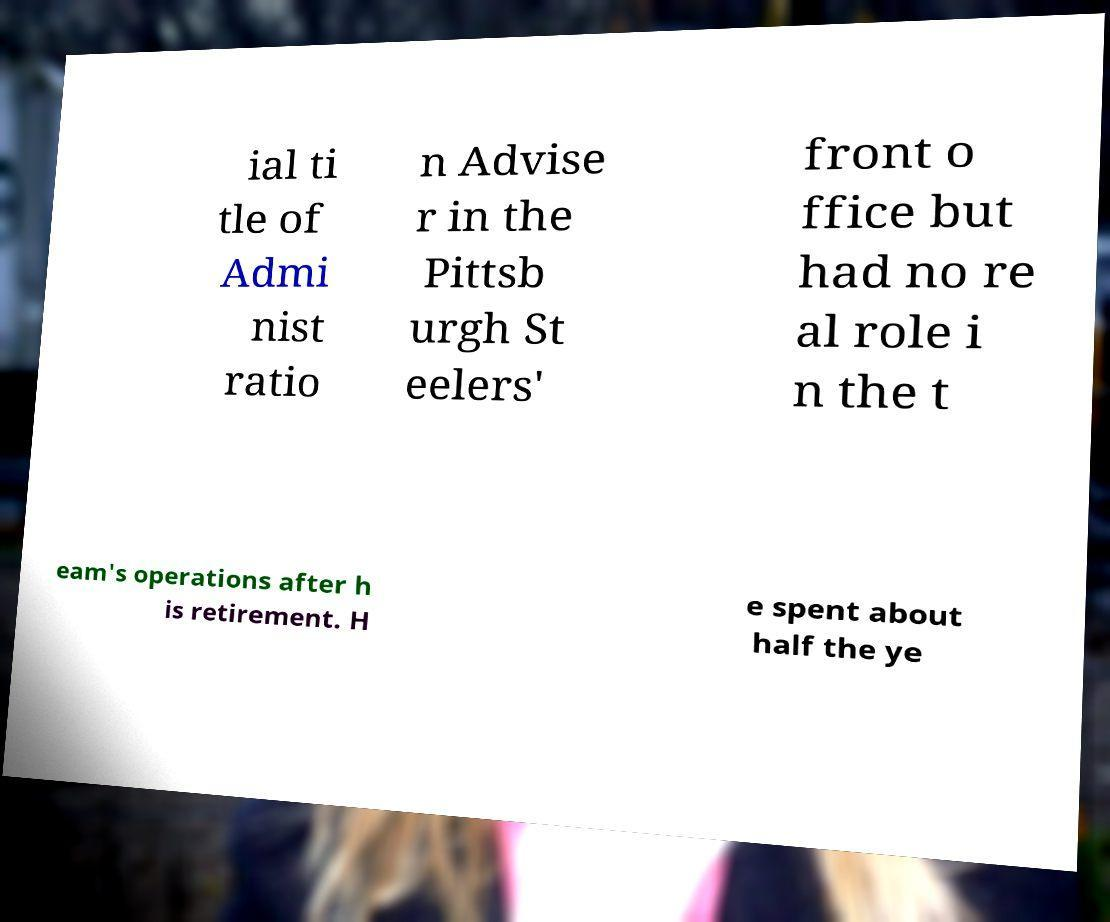I need the written content from this picture converted into text. Can you do that? ial ti tle of Admi nist ratio n Advise r in the Pittsb urgh St eelers' front o ffice but had no re al role i n the t eam's operations after h is retirement. H e spent about half the ye 